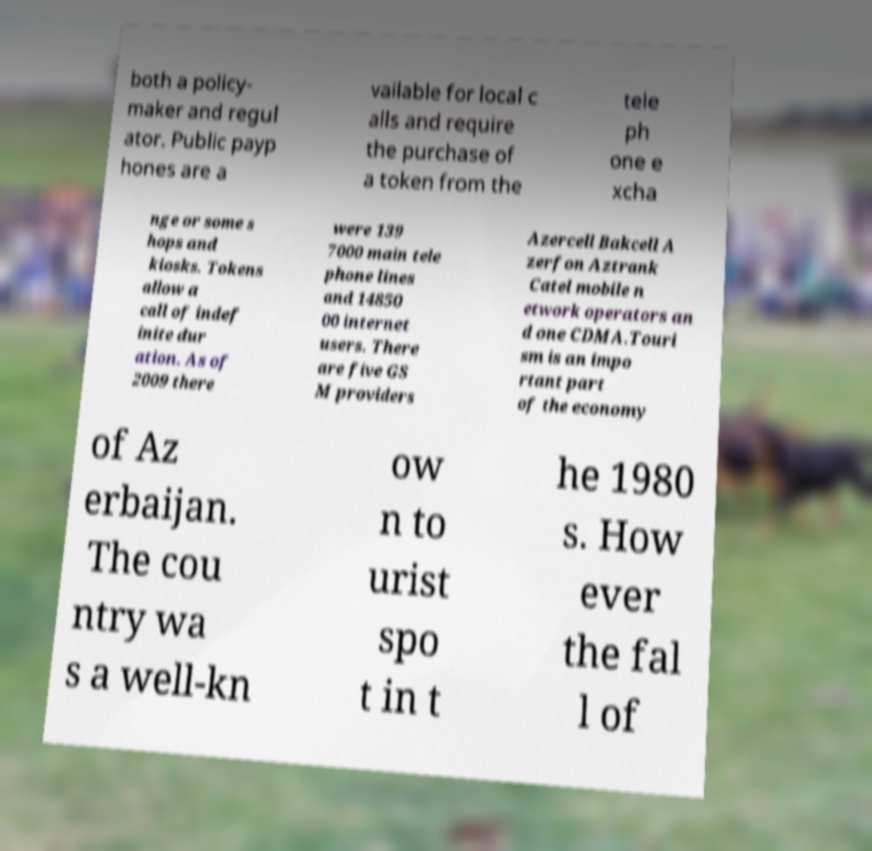What messages or text are displayed in this image? I need them in a readable, typed format. both a policy- maker and regul ator. Public payp hones are a vailable for local c alls and require the purchase of a token from the tele ph one e xcha nge or some s hops and kiosks. Tokens allow a call of indef inite dur ation. As of 2009 there were 139 7000 main tele phone lines and 14850 00 internet users. There are five GS M providers Azercell Bakcell A zerfon Aztrank Catel mobile n etwork operators an d one CDMA.Touri sm is an impo rtant part of the economy of Az erbaijan. The cou ntry wa s a well-kn ow n to urist spo t in t he 1980 s. How ever the fal l of 